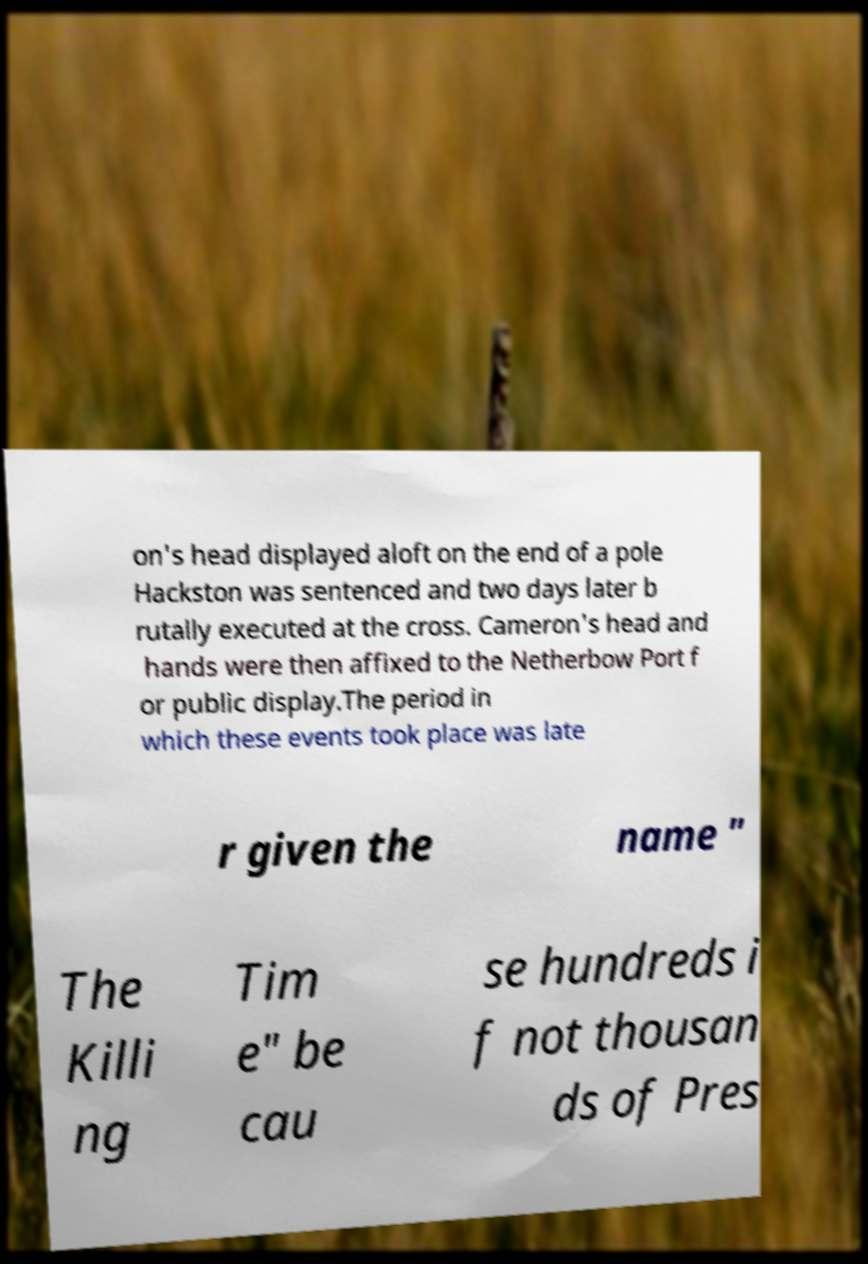For documentation purposes, I need the text within this image transcribed. Could you provide that? on's head displayed aloft on the end of a pole Hackston was sentenced and two days later b rutally executed at the cross. Cameron's head and hands were then affixed to the Netherbow Port f or public display.The period in which these events took place was late r given the name " The Killi ng Tim e" be cau se hundreds i f not thousan ds of Pres 